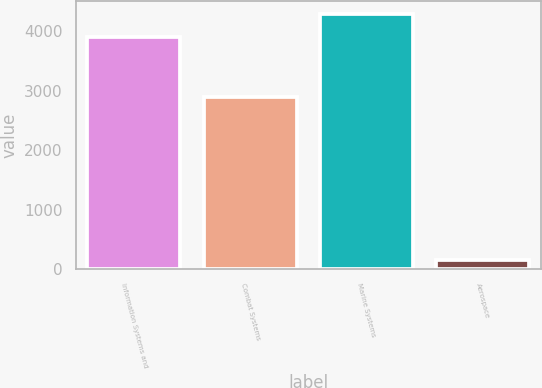<chart> <loc_0><loc_0><loc_500><loc_500><bar_chart><fcel>Information Systems and<fcel>Combat Systems<fcel>Marine Systems<fcel>Aerospace<nl><fcel>3907<fcel>2890<fcel>4287.8<fcel>158<nl></chart> 